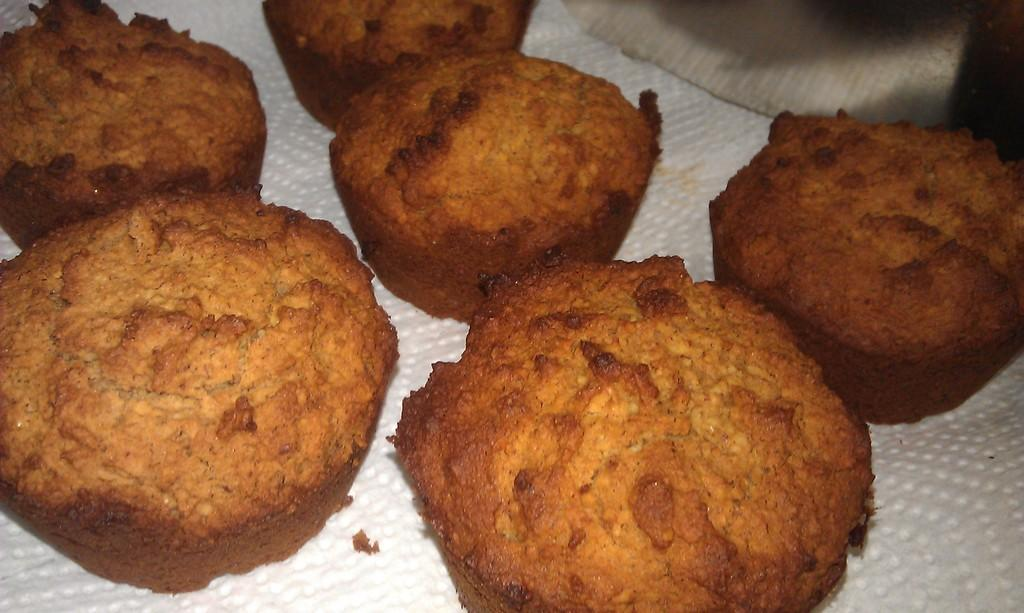What type of food can be seen in the image? There are cookies in the image. What is located at the bottom of the image? There is a tissue paper at the bottom of the image. Can you describe anything in the background of the image? There might be a cloth in the background of the image. What type of quartz can be seen in the image? There is no quartz present in the image. What sound can be heard coming from the box in the image? There is no box or sound present in the image. 